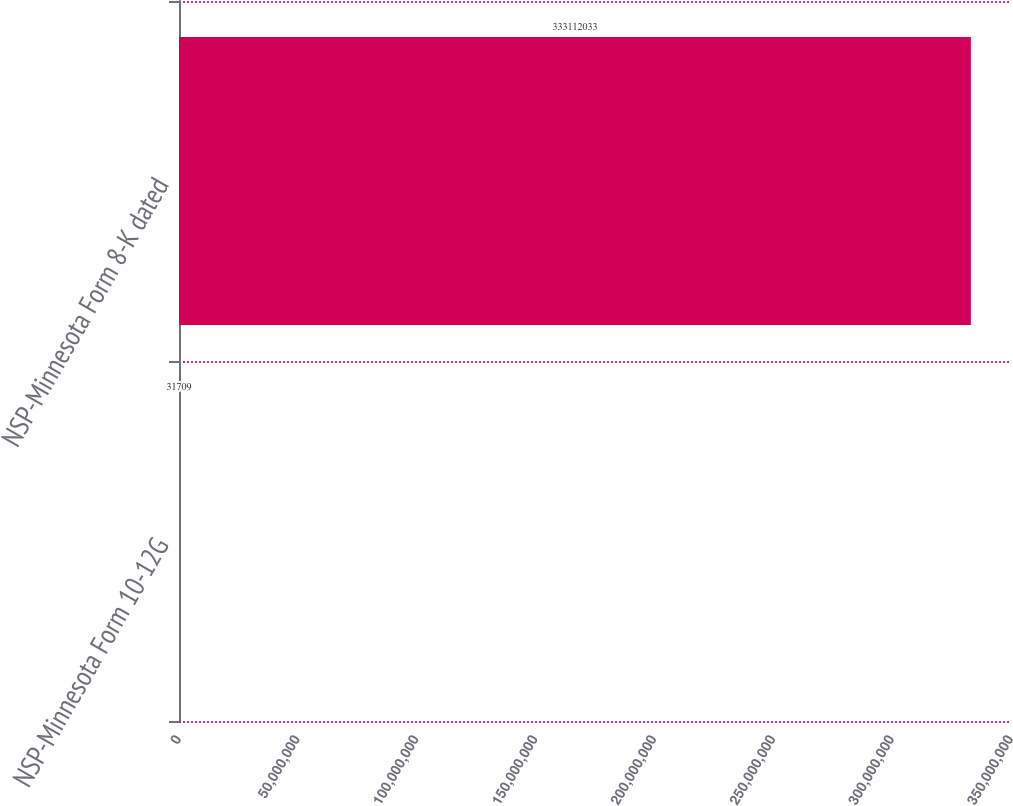<chart> <loc_0><loc_0><loc_500><loc_500><bar_chart><fcel>NSP-Minnesota Form 10-12G<fcel>NSP-Minnesota Form 8-K dated<nl><fcel>31709<fcel>3.33112e+08<nl></chart> 